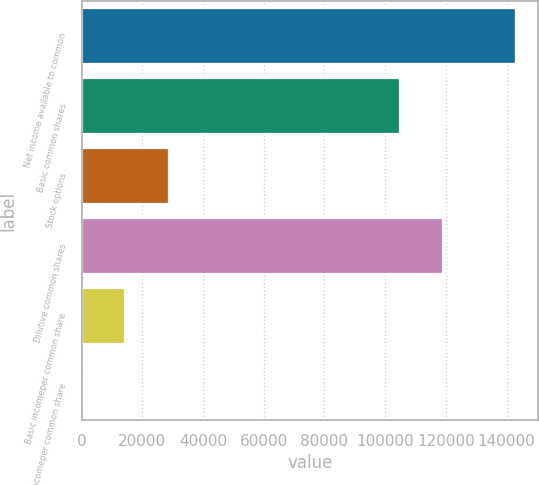Convert chart. <chart><loc_0><loc_0><loc_500><loc_500><bar_chart><fcel>Net income available to common<fcel>Basic common shares<fcel>Stock options<fcel>Dilutive common shares<fcel>Basic incomeper common share<fcel>Diluted incomeper common share<nl><fcel>143264<fcel>104890<fcel>28653.9<fcel>119216<fcel>14327.6<fcel>1.33<nl></chart> 